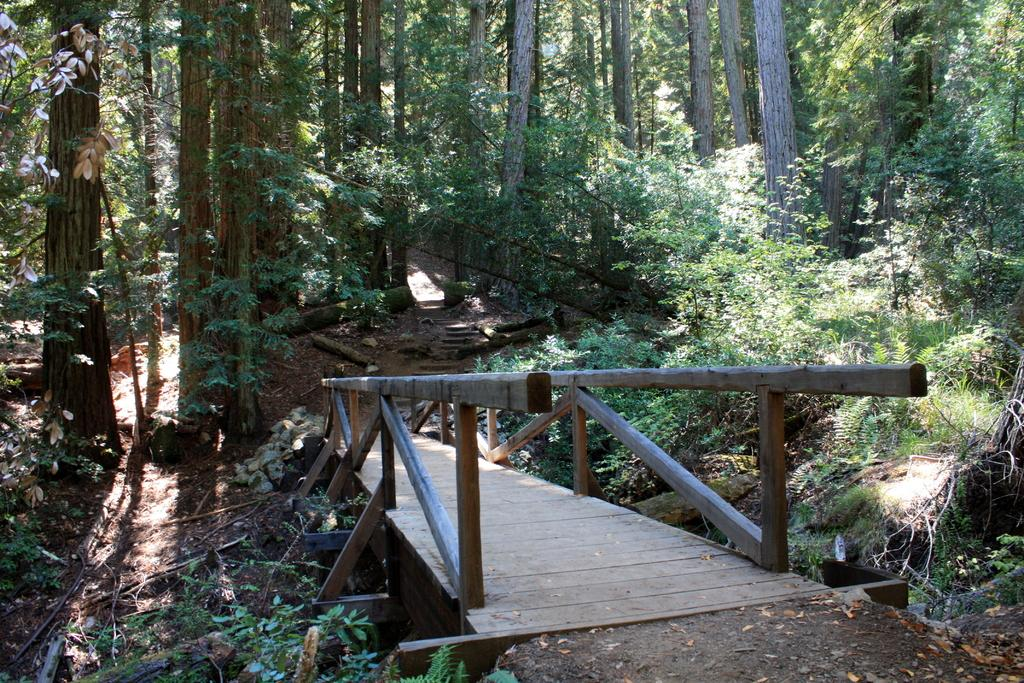What structure can be seen in the image? There is a bridge in the image. What type of vegetation is present in the image? There are trees in the image. What can be observed on the ground or surfaces in the image? Shadows are visible in the image. Where is the bomb hidden in the image? There is no bomb present in the image. What type of cord is used to hang the fact from the tree in the image? There is no fact or cord present in the image. 